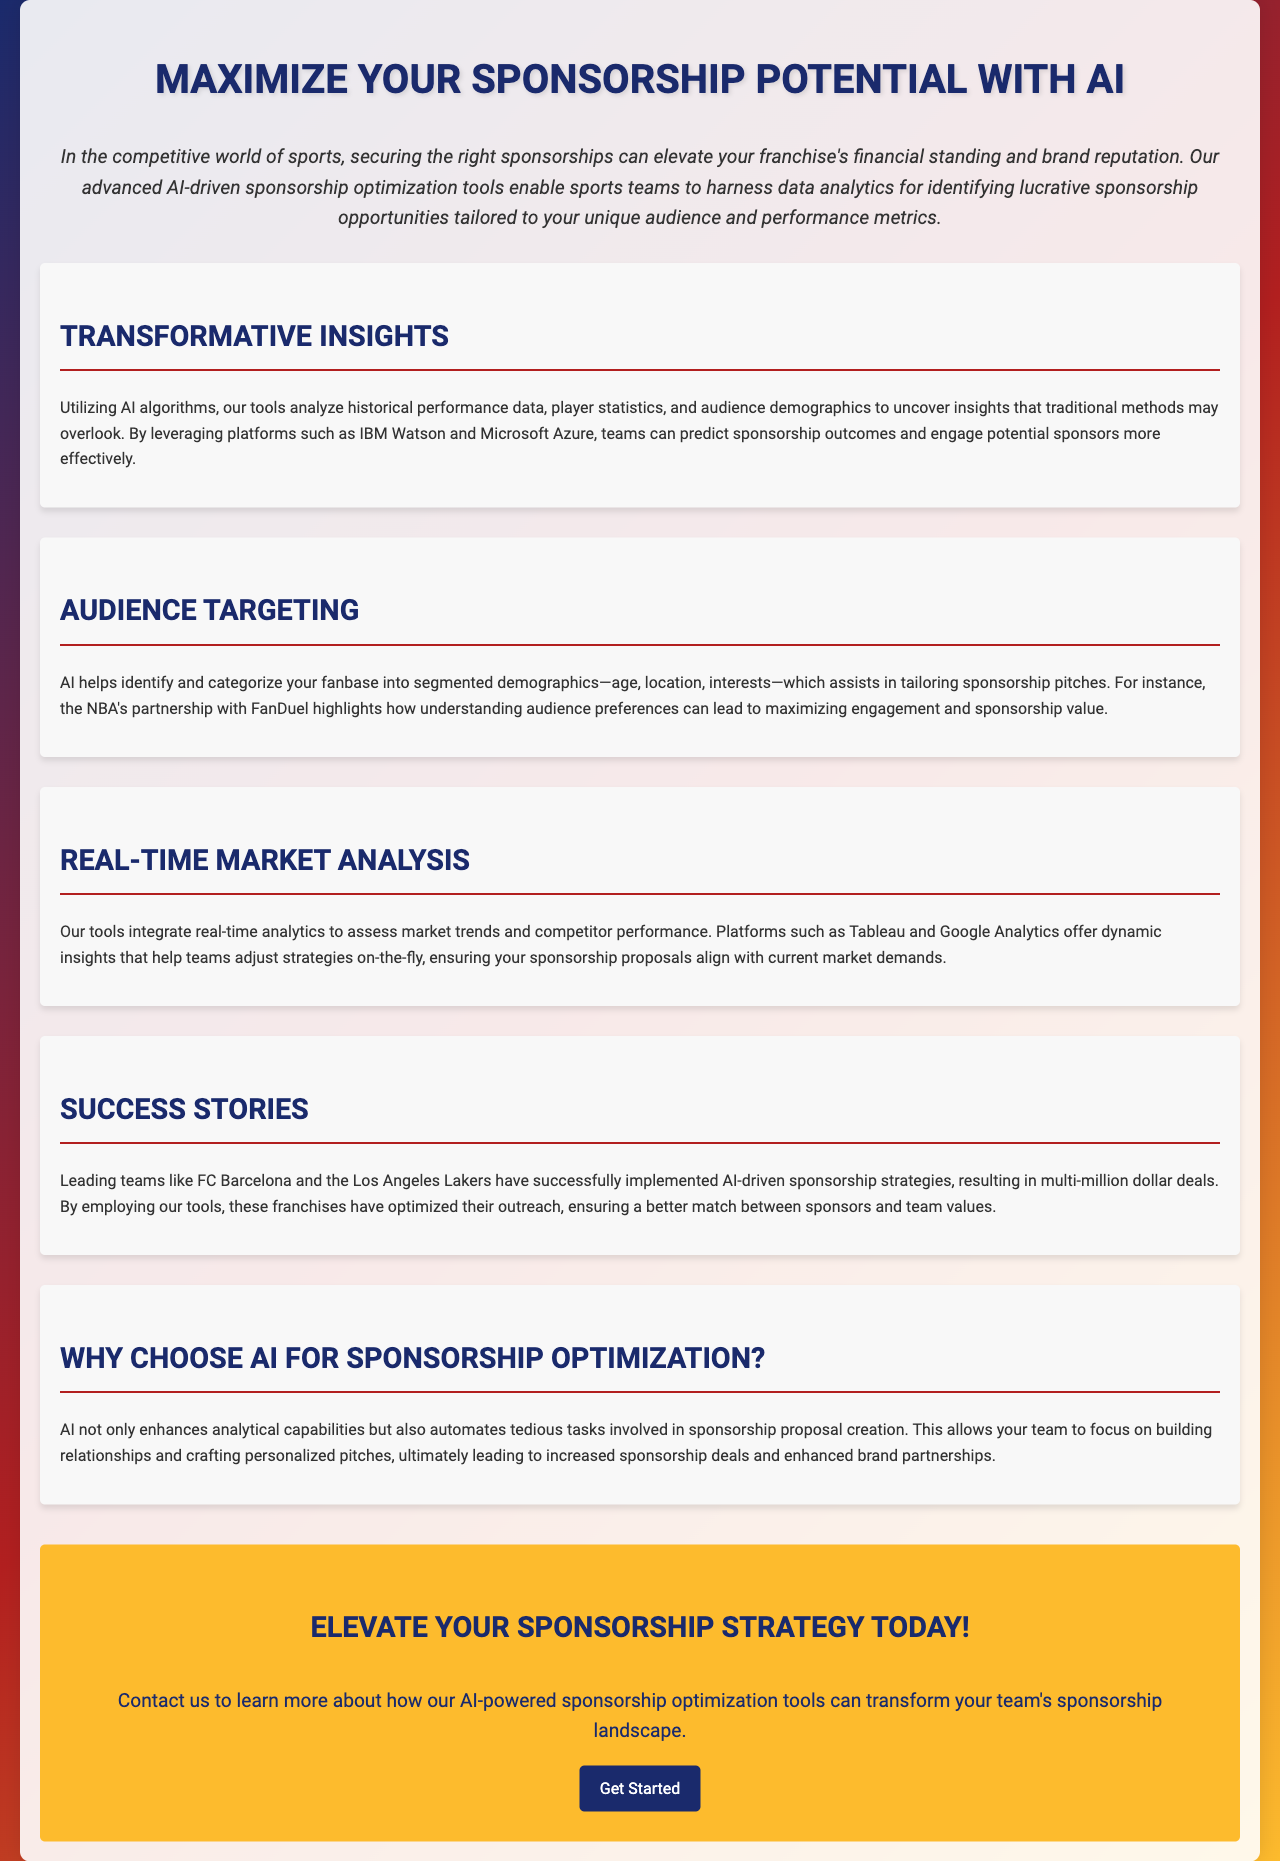What is the main focus of the brochure? The brochure focuses on AI-driven sponsorship optimization tools for sports teams.
Answer: AI-driven sponsorship optimization tools What major teams are mentioned as success stories? The brochure highlights successful implementation by teams such as FC Barcelona and the Los Angeles Lakers.
Answer: FC Barcelona and the Los Angeles Lakers What does AI assist with in audience targeting? AI assists in identifying and categorizing the fanbase into segmented demographics, such as age, location, and interests.
Answer: Segmented demographics Which AI platforms are mentioned for predictive analysis? The brochure mentions platforms like IBM Watson and Microsoft Azure for predictive analysis.
Answer: IBM Watson and Microsoft Azure What is the call to action in the document? The call to action encourages readers to contact the company to learn more about AI-powered tools.
Answer: Contact us to learn more What type of analytics does the tool integrate? The tool integrates real-time analytics to assess market trends and competitor performance.
Answer: Real-time analytics What effect does AI have on sponsorship proposal creation? AI automates tedious tasks involved in sponsorship proposal creation.
Answer: Automates tedious tasks How can teams adjust their strategies according to the document? Teams can adjust their strategies on-the-fly using dynamic insights from tools like Tableau and Google Analytics.
Answer: Dynamic insights from Tableau and Google Analytics 